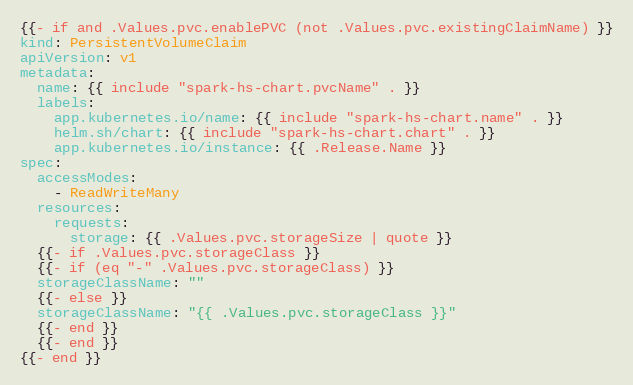<code> <loc_0><loc_0><loc_500><loc_500><_YAML_>{{- if and .Values.pvc.enablePVC (not .Values.pvc.existingClaimName) }}
kind: PersistentVolumeClaim
apiVersion: v1
metadata:
  name: {{ include "spark-hs-chart.pvcName" . }}
  labels:
    app.kubernetes.io/name: {{ include "spark-hs-chart.name" . }}
    helm.sh/chart: {{ include "spark-hs-chart.chart" . }}
    app.kubernetes.io/instance: {{ .Release.Name }}
spec:
  accessModes:
    - ReadWriteMany
  resources:
    requests:
      storage: {{ .Values.pvc.storageSize | quote }}
  {{- if .Values.pvc.storageClass }}
  {{- if (eq "-" .Values.pvc.storageClass) }}
  storageClassName: ""
  {{- else }}
  storageClassName: "{{ .Values.pvc.storageClass }}"
  {{- end }}
  {{- end }}
{{- end }}
</code> 